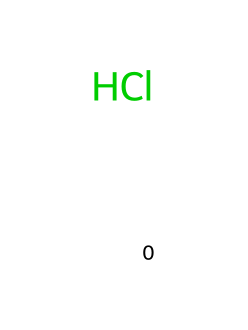How many atoms are in hydrochloric acid? The SMILES representation [H]Cl indicates there is one hydrogen atom and one chlorine atom. Thus, the total count of atoms is 2.
Answer: 2 What type of bond exists between hydrogen and chlorine in hydrochloric acid? The SMILES notation [H]Cl shows that hydrogen is bonded to chlorine by a single covalent bond, which is typical for diatomic molecules like HCl.
Answer: single covalent bond How does hydrochloric acid contribute to digestion? Hydrochloric acid creates an acidic environment in the stomach, which is necessary for activating digestive enzymes and breaking down food.
Answer: activates enzymes What is the effect of hydrochloric acid's pH level on the stomach? Hydrochloric acid has a very low pH, typically around 1-2, which is critical for maintaining the stomach's acidic environment, aiding in digestion, and protecting against pathogens.
Answer: low pH Why is hydrochloric acid classified as a strong acid? Hydrochloric acid completely dissociates in water, producing a high concentration of hydrogen ions, which is characteristic of strong acids.
Answer: completely dissociates What would happen if hydrochloric acid were neutralized? Neutralization of hydrochloric acid typically involves adding a base, leading to the formation of salt and water, thus raising the pH of the solution to a neutral level.
Answer: forms salt and water 